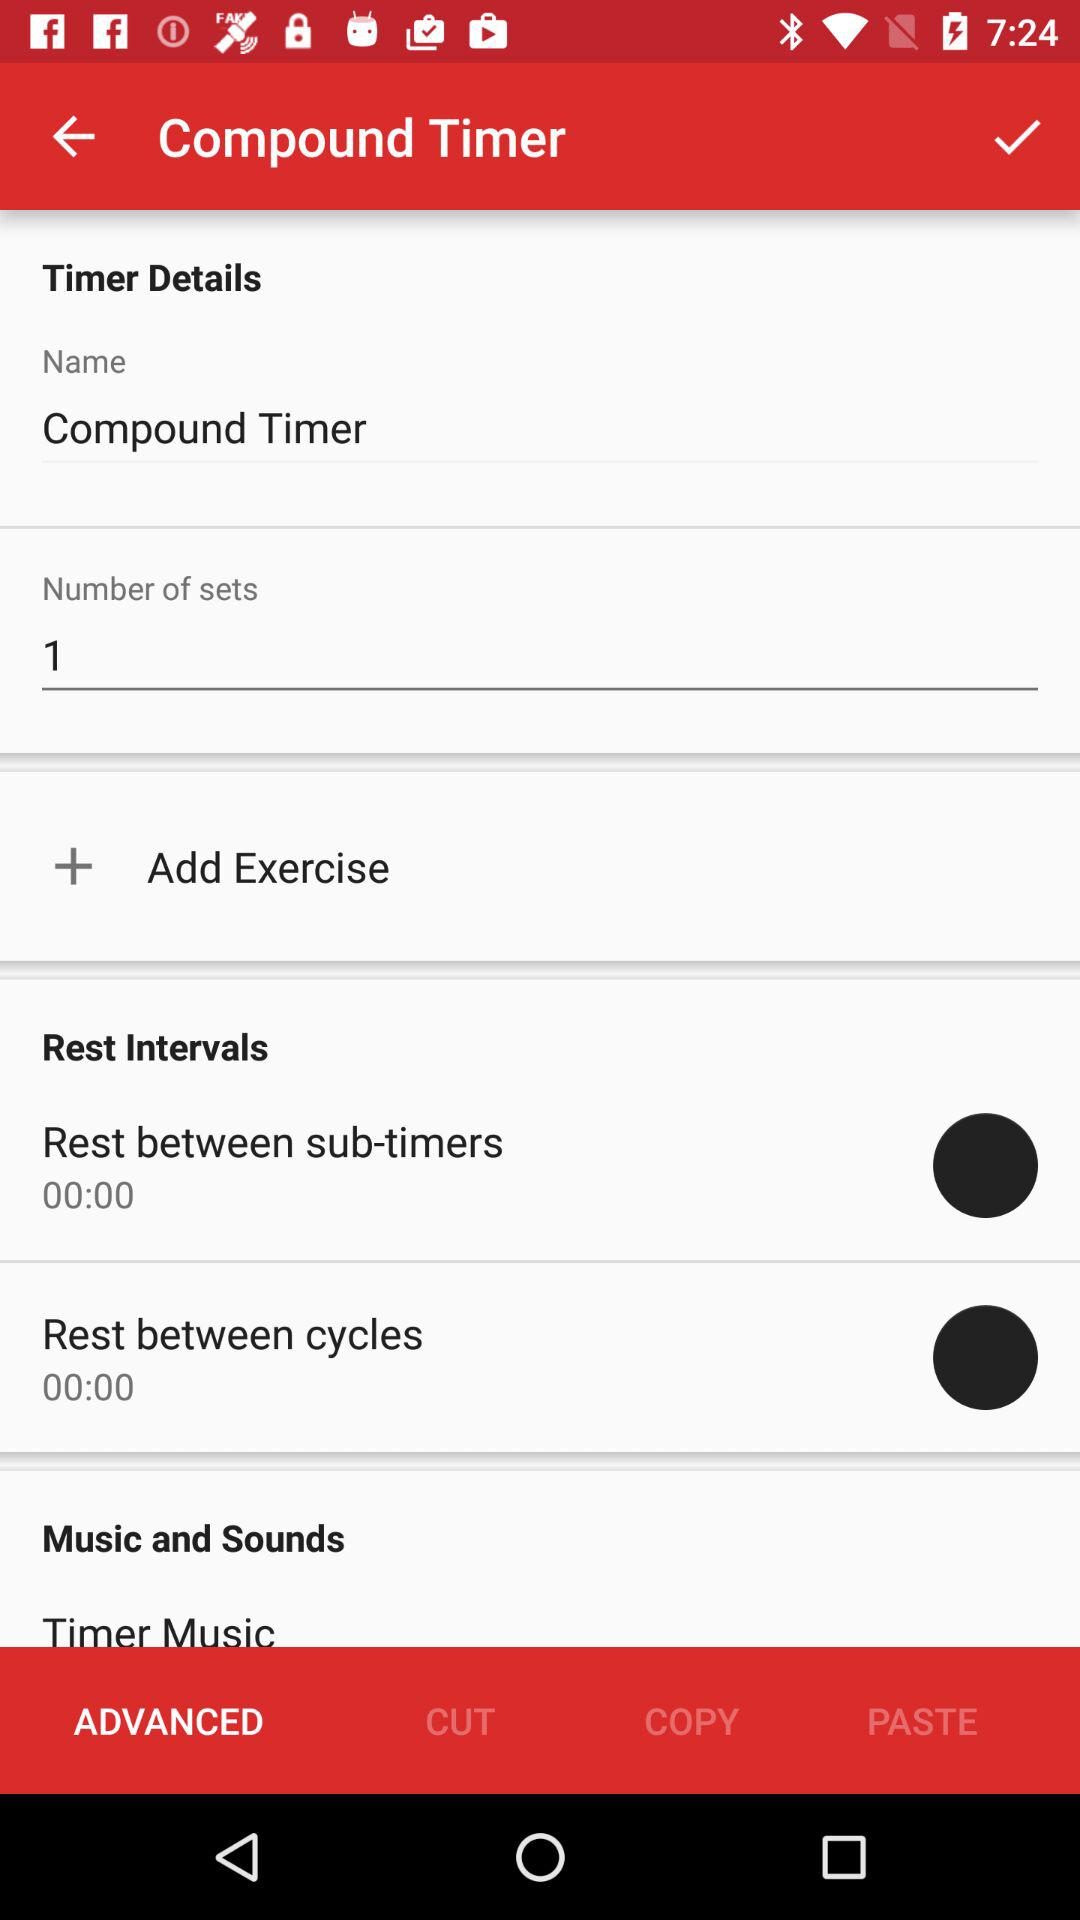What is the number of sets? The number of sets is 1. 